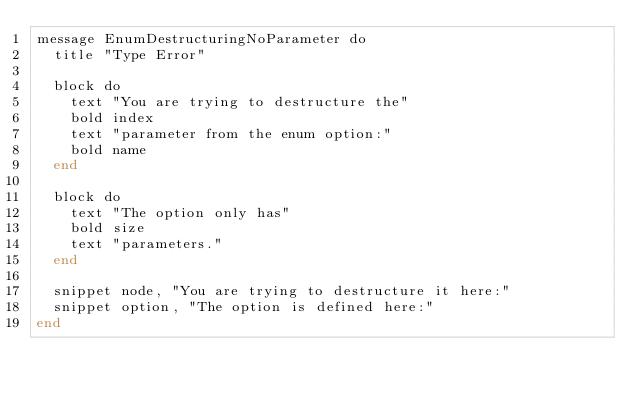<code> <loc_0><loc_0><loc_500><loc_500><_Crystal_>message EnumDestructuringNoParameter do
  title "Type Error"

  block do
    text "You are trying to destructure the"
    bold index
    text "parameter from the enum option:"
    bold name
  end

  block do
    text "The option only has"
    bold size
    text "parameters."
  end

  snippet node, "You are trying to destructure it here:"
  snippet option, "The option is defined here:"
end
</code> 